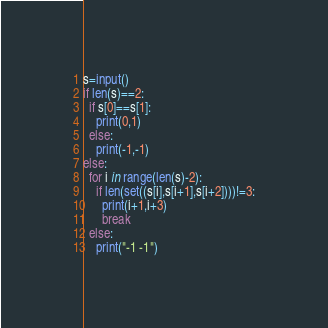Convert code to text. <code><loc_0><loc_0><loc_500><loc_500><_Python_>s=input()
if len(s)==2:
  if s[0]==s[1]:
    print(0,1)
  else:
    print(-1,-1)
else:
  for i in range(len(s)-2):
    if len(set((s[i],s[i+1],s[i+2])))!=3:
      print(i+1,i+3)
      break
  else:
    print("-1 -1")</code> 